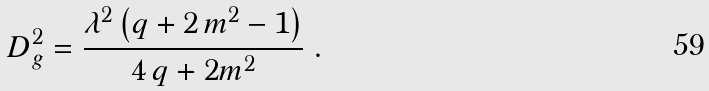Convert formula to latex. <formula><loc_0><loc_0><loc_500><loc_500>D _ { g } ^ { 2 } = { \frac { { \lambda } ^ { 2 } \left ( q + 2 \, { m } ^ { 2 } - 1 \right ) } { 4 \, q + 2 { m } ^ { 2 } } } \ .</formula> 